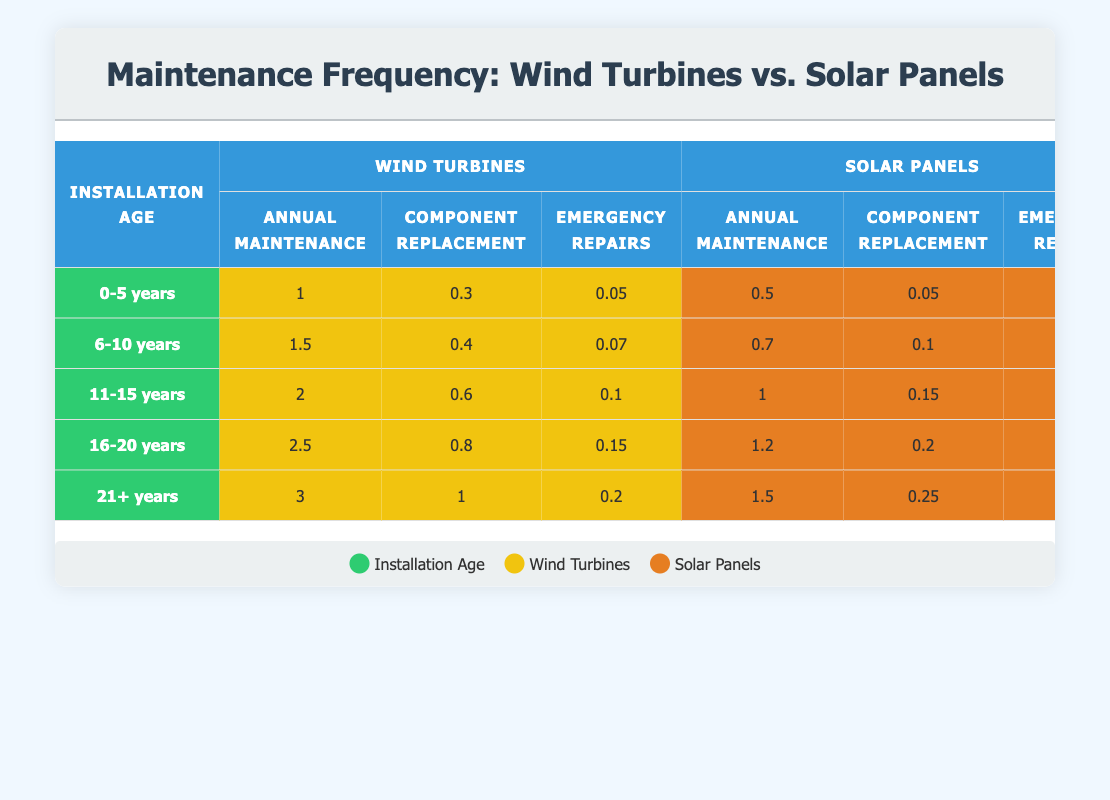What is the annual maintenance frequency for wind turbines that are 11-15 years old? For wind turbines aged 11-15 years, the annual maintenance frequency is listed in the table as 2.
Answer: 2 What is the component replacement for solar panels aged 16-20 years? In the table, the component replacement for solar panels with an installation age of 16-20 years is given as 0.2.
Answer: 0.2 Are the emergency repairs for solar panels higher than for wind turbines in the 0-5 years category? In the 0-5 years age category, solar panels have emergency repairs of 0.02, while wind turbines have 0.05. Since 0.02 is less than 0.05, the answer is no.
Answer: No What is the total annual maintenance frequency for wind turbines and solar panels that are 21+ years old? For this age category, the annual maintenance for wind turbines is 3 and for solar panels is 1.5. Summing these gives 3 + 1.5 = 4.5.
Answer: 4.5 What is the increase in emergency repairs for wind turbines from the 6-10 years category to the 21+ years category? The emergency repairs for wind turbines aged 6-10 years is 0.07 and for those aged 21+ years is 0.2. The increase is calculated as 0.2 - 0.07 = 0.13.
Answer: 0.13 Is the component replacement for wind turbines in the 11-15 years category greater than for solar panels in the same category? The table shows that component replacement for wind turbines is 0.6 and for solar panels is 0.15. Since 0.6 is greater than 0.15, the answer is yes.
Answer: Yes What is the average annual maintenance frequency for solar panels across all installation ages? The annual maintenance frequencies for solar panels at each installation age are 0.5, 0.7, 1, 1.2, and 1.5. Summing these: 0.5 + 0.7 + 1 + 1.2 + 1.5 = 5. The average is then 5/5 = 1.
Answer: 1 How much higher is the component replacement for wind turbines than for solar panels in the 16-20 years category? For the 16-20 years category, the component replacement for wind turbines is 0.8 and for solar panels is 0.2. The difference is 0.8 - 0.2 = 0.6.
Answer: 0.6 What pattern can be observed in the maintenance frequencies as the installation age of wind turbines increases? By analyzing the table, it is evident that the maintenance frequencies for wind turbines increase consistently with older installation ages across all categories of maintenance.
Answer: Maintenance frequency increases with age 